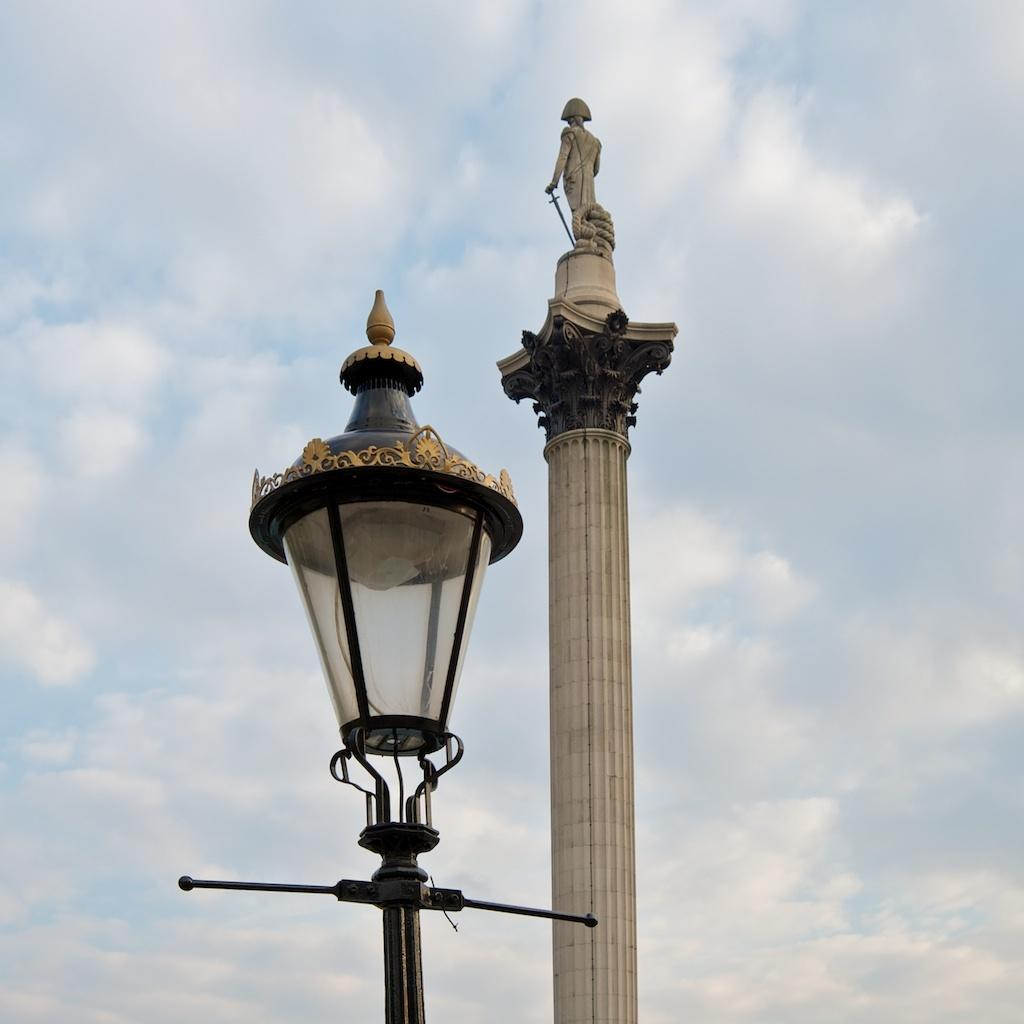What is the main structure in the image? There is a pillar in the image. What is on top of the pillar? There is a sculpture on the pillar. What other object is near the pillar? There is a light with a stand beside the pillar. What can be seen in the background of the image? The sky is visible behind the pillar. What type of wood is used to make the string in the image? There is no wood or string present in the image. 